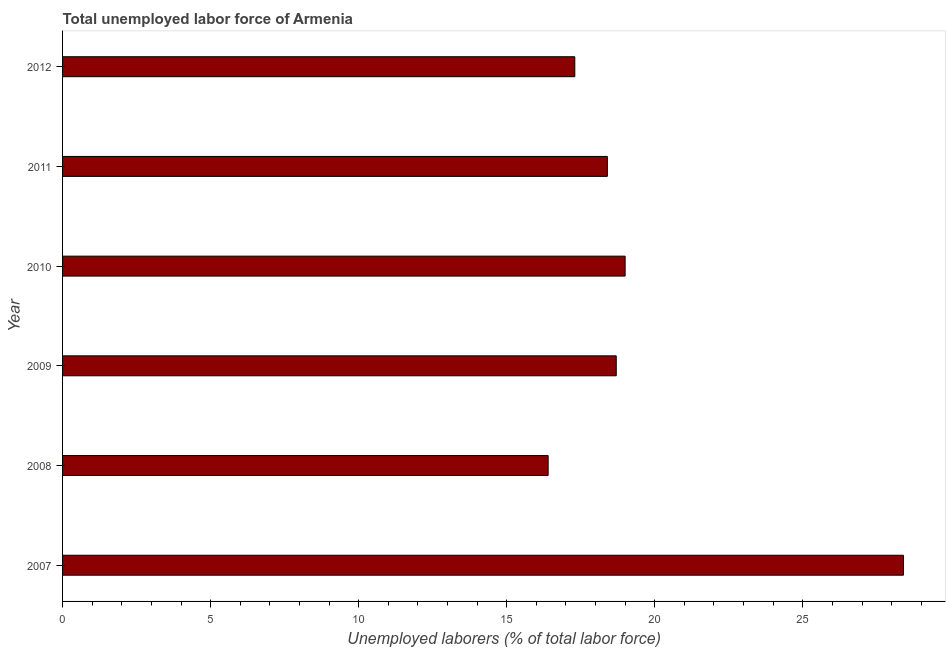What is the title of the graph?
Make the answer very short. Total unemployed labor force of Armenia. What is the label or title of the X-axis?
Make the answer very short. Unemployed laborers (% of total labor force). What is the label or title of the Y-axis?
Offer a terse response. Year. What is the total unemployed labour force in 2008?
Ensure brevity in your answer.  16.4. Across all years, what is the maximum total unemployed labour force?
Provide a short and direct response. 28.4. Across all years, what is the minimum total unemployed labour force?
Your answer should be compact. 16.4. In which year was the total unemployed labour force minimum?
Your answer should be very brief. 2008. What is the sum of the total unemployed labour force?
Ensure brevity in your answer.  118.2. What is the difference between the total unemployed labour force in 2007 and 2010?
Make the answer very short. 9.4. What is the average total unemployed labour force per year?
Make the answer very short. 19.7. What is the median total unemployed labour force?
Offer a terse response. 18.55. In how many years, is the total unemployed labour force greater than 23 %?
Provide a succinct answer. 1. Do a majority of the years between 2009 and 2012 (inclusive) have total unemployed labour force greater than 19 %?
Ensure brevity in your answer.  No. What is the ratio of the total unemployed labour force in 2009 to that in 2011?
Offer a terse response. 1.02. Are all the bars in the graph horizontal?
Keep it short and to the point. Yes. Are the values on the major ticks of X-axis written in scientific E-notation?
Your answer should be very brief. No. What is the Unemployed laborers (% of total labor force) of 2007?
Make the answer very short. 28.4. What is the Unemployed laborers (% of total labor force) of 2008?
Offer a terse response. 16.4. What is the Unemployed laborers (% of total labor force) in 2009?
Your response must be concise. 18.7. What is the Unemployed laborers (% of total labor force) in 2011?
Offer a very short reply. 18.4. What is the Unemployed laborers (% of total labor force) of 2012?
Provide a short and direct response. 17.3. What is the difference between the Unemployed laborers (% of total labor force) in 2007 and 2009?
Make the answer very short. 9.7. What is the difference between the Unemployed laborers (% of total labor force) in 2007 and 2010?
Provide a succinct answer. 9.4. What is the difference between the Unemployed laborers (% of total labor force) in 2007 and 2011?
Provide a succinct answer. 10. What is the difference between the Unemployed laborers (% of total labor force) in 2008 and 2011?
Offer a very short reply. -2. What is the difference between the Unemployed laborers (% of total labor force) in 2008 and 2012?
Offer a terse response. -0.9. What is the difference between the Unemployed laborers (% of total labor force) in 2009 and 2011?
Give a very brief answer. 0.3. What is the difference between the Unemployed laborers (% of total labor force) in 2009 and 2012?
Give a very brief answer. 1.4. What is the difference between the Unemployed laborers (% of total labor force) in 2010 and 2011?
Keep it short and to the point. 0.6. What is the difference between the Unemployed laborers (% of total labor force) in 2010 and 2012?
Provide a short and direct response. 1.7. What is the ratio of the Unemployed laborers (% of total labor force) in 2007 to that in 2008?
Your answer should be very brief. 1.73. What is the ratio of the Unemployed laborers (% of total labor force) in 2007 to that in 2009?
Offer a very short reply. 1.52. What is the ratio of the Unemployed laborers (% of total labor force) in 2007 to that in 2010?
Your response must be concise. 1.5. What is the ratio of the Unemployed laborers (% of total labor force) in 2007 to that in 2011?
Your answer should be compact. 1.54. What is the ratio of the Unemployed laborers (% of total labor force) in 2007 to that in 2012?
Ensure brevity in your answer.  1.64. What is the ratio of the Unemployed laborers (% of total labor force) in 2008 to that in 2009?
Your answer should be very brief. 0.88. What is the ratio of the Unemployed laborers (% of total labor force) in 2008 to that in 2010?
Make the answer very short. 0.86. What is the ratio of the Unemployed laborers (% of total labor force) in 2008 to that in 2011?
Provide a short and direct response. 0.89. What is the ratio of the Unemployed laborers (% of total labor force) in 2008 to that in 2012?
Offer a very short reply. 0.95. What is the ratio of the Unemployed laborers (% of total labor force) in 2009 to that in 2012?
Provide a succinct answer. 1.08. What is the ratio of the Unemployed laborers (% of total labor force) in 2010 to that in 2011?
Provide a succinct answer. 1.03. What is the ratio of the Unemployed laborers (% of total labor force) in 2010 to that in 2012?
Give a very brief answer. 1.1. What is the ratio of the Unemployed laborers (% of total labor force) in 2011 to that in 2012?
Ensure brevity in your answer.  1.06. 